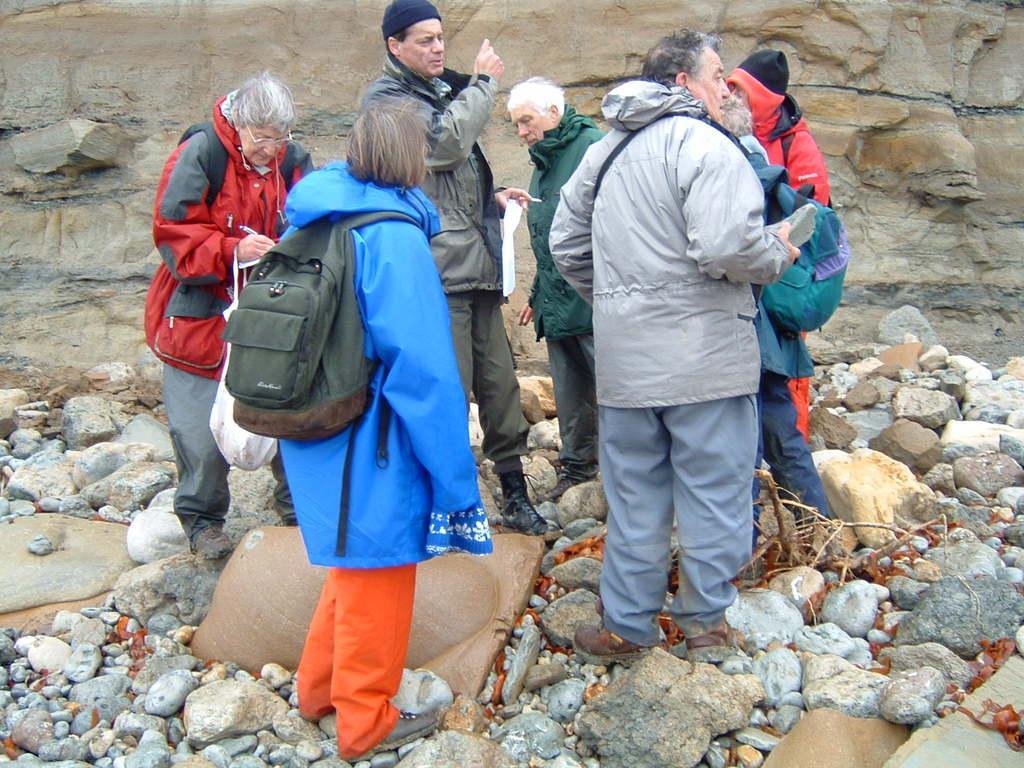Please provide a concise description of this image. This image consists of of seven persons. In the front, the woman wearing blue coat is wearing a backpack. At the bottom there are many rocks. In the background there is a mountain rack. To the left, the is wearing red jacket. 